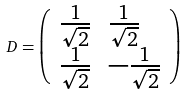Convert formula to latex. <formula><loc_0><loc_0><loc_500><loc_500>D = \left ( \begin{array} { l l } { { \frac { 1 } { \sqrt { 2 } } } } & { { \frac { 1 } { \sqrt { 2 } } } } \\ { { \frac { 1 } { \sqrt { 2 } } } } & { { - \frac { 1 } { \sqrt { 2 } } } } \end{array} \right )</formula> 